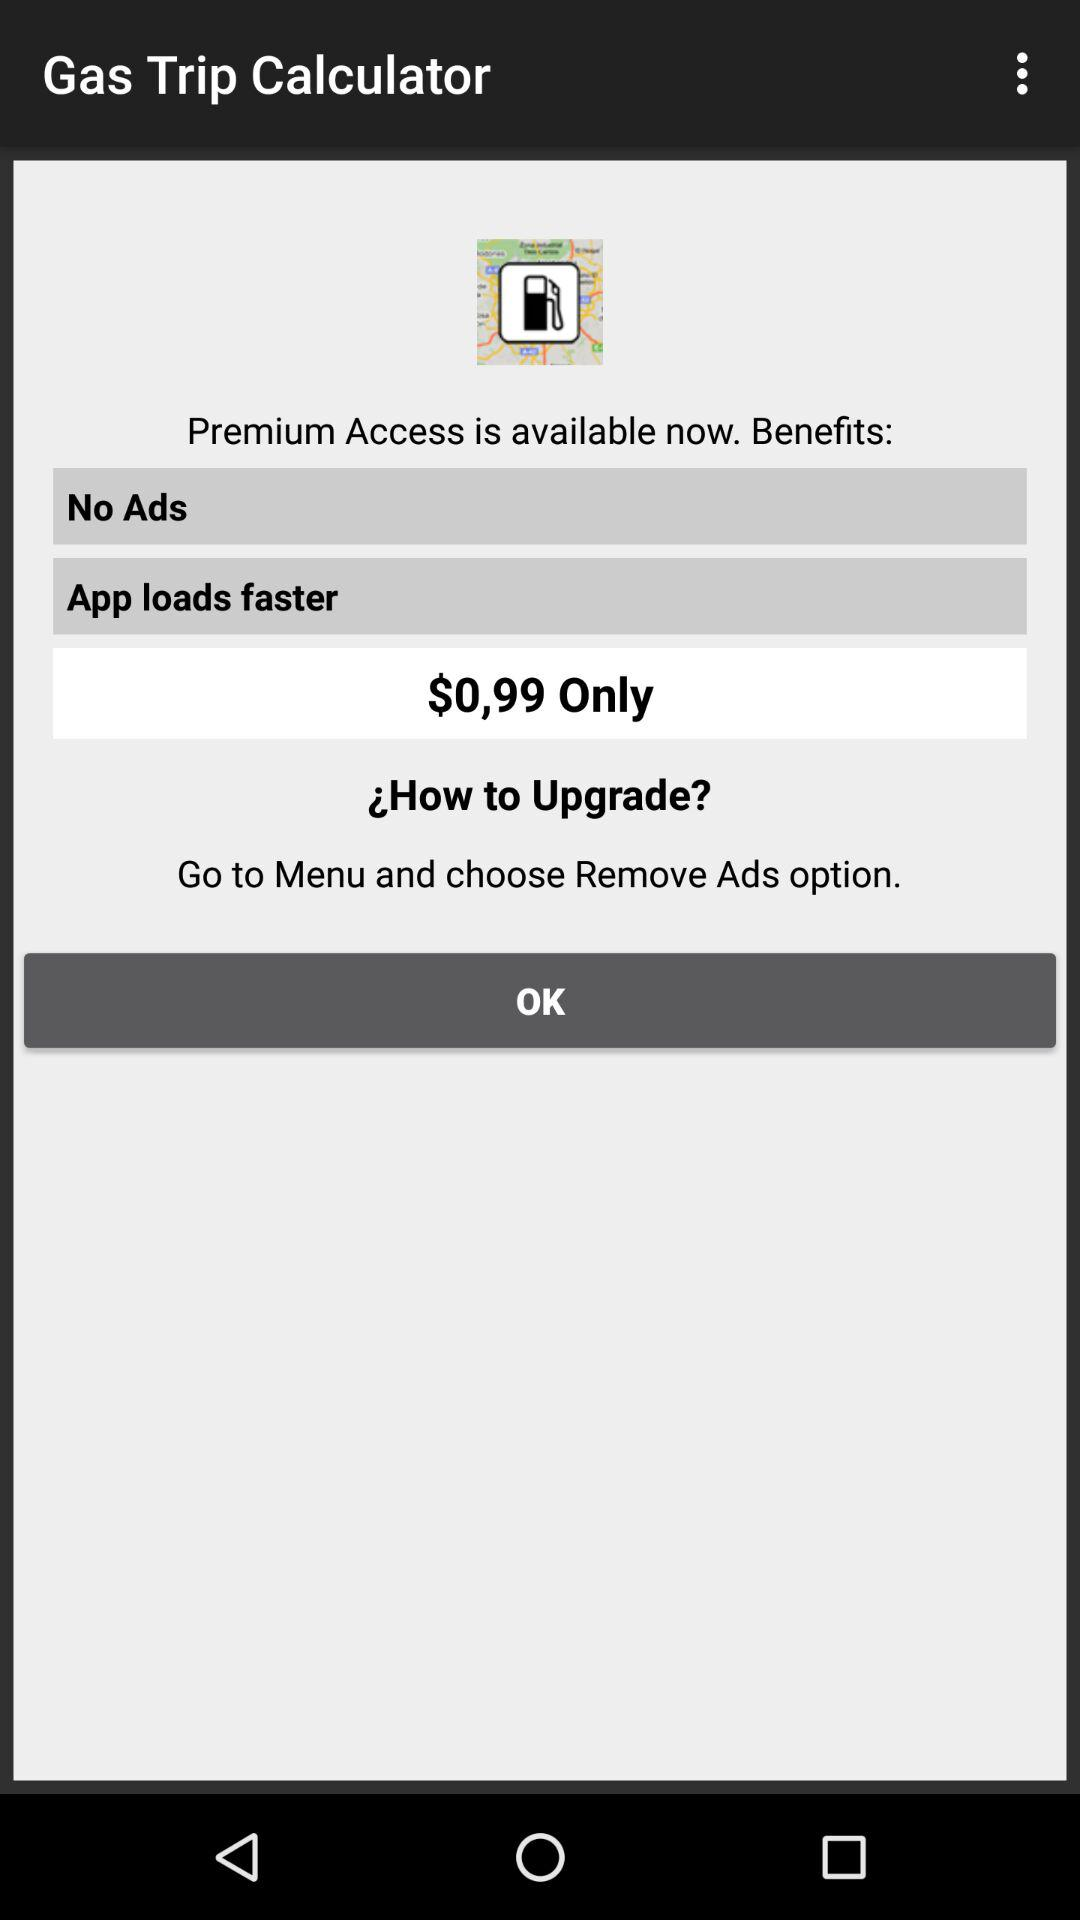What is the cost of premium access? The cost of premium access is $0.99. 